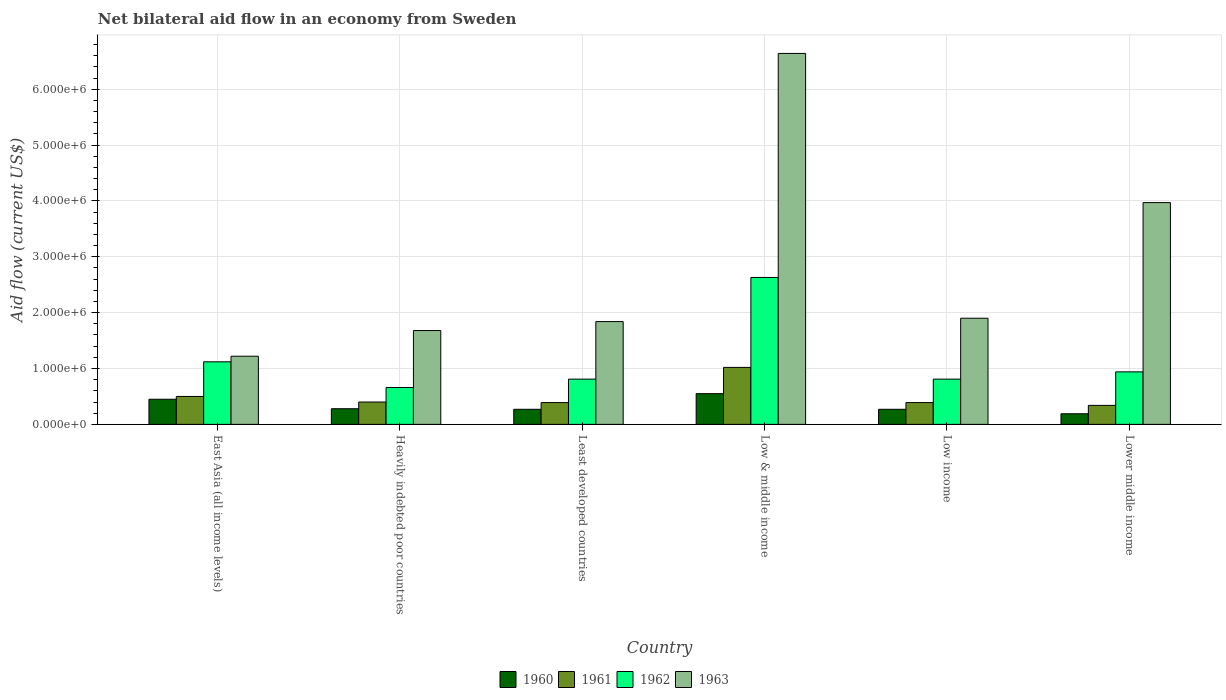Are the number of bars per tick equal to the number of legend labels?
Provide a succinct answer. Yes. Are the number of bars on each tick of the X-axis equal?
Make the answer very short. Yes. How many bars are there on the 6th tick from the left?
Keep it short and to the point. 4. How many bars are there on the 2nd tick from the right?
Make the answer very short. 4. What is the label of the 4th group of bars from the left?
Your answer should be compact. Low & middle income. What is the net bilateral aid flow in 1963 in Least developed countries?
Give a very brief answer. 1.84e+06. Across all countries, what is the maximum net bilateral aid flow in 1963?
Your response must be concise. 6.64e+06. In which country was the net bilateral aid flow in 1962 maximum?
Provide a short and direct response. Low & middle income. In which country was the net bilateral aid flow in 1961 minimum?
Offer a very short reply. Lower middle income. What is the total net bilateral aid flow in 1962 in the graph?
Offer a very short reply. 6.97e+06. What is the difference between the net bilateral aid flow in 1961 in Heavily indebted poor countries and that in Low & middle income?
Ensure brevity in your answer.  -6.20e+05. What is the average net bilateral aid flow in 1963 per country?
Your answer should be very brief. 2.88e+06. In how many countries, is the net bilateral aid flow in 1961 greater than 3200000 US$?
Provide a short and direct response. 0. What is the ratio of the net bilateral aid flow in 1962 in East Asia (all income levels) to that in Heavily indebted poor countries?
Your answer should be compact. 1.7. Is the net bilateral aid flow in 1963 in Low & middle income less than that in Lower middle income?
Provide a succinct answer. No. What is the difference between the highest and the lowest net bilateral aid flow in 1962?
Your answer should be compact. 1.97e+06. In how many countries, is the net bilateral aid flow in 1963 greater than the average net bilateral aid flow in 1963 taken over all countries?
Provide a short and direct response. 2. What does the 4th bar from the right in Low & middle income represents?
Provide a succinct answer. 1960. Is it the case that in every country, the sum of the net bilateral aid flow in 1960 and net bilateral aid flow in 1963 is greater than the net bilateral aid flow in 1961?
Ensure brevity in your answer.  Yes. How many bars are there?
Your answer should be compact. 24. Are all the bars in the graph horizontal?
Provide a succinct answer. No. How many countries are there in the graph?
Your answer should be compact. 6. What is the difference between two consecutive major ticks on the Y-axis?
Your response must be concise. 1.00e+06. Are the values on the major ticks of Y-axis written in scientific E-notation?
Give a very brief answer. Yes. Where does the legend appear in the graph?
Your response must be concise. Bottom center. How many legend labels are there?
Offer a very short reply. 4. What is the title of the graph?
Make the answer very short. Net bilateral aid flow in an economy from Sweden. What is the label or title of the Y-axis?
Your answer should be compact. Aid flow (current US$). What is the Aid flow (current US$) in 1962 in East Asia (all income levels)?
Offer a very short reply. 1.12e+06. What is the Aid flow (current US$) of 1963 in East Asia (all income levels)?
Your response must be concise. 1.22e+06. What is the Aid flow (current US$) of 1961 in Heavily indebted poor countries?
Keep it short and to the point. 4.00e+05. What is the Aid flow (current US$) of 1963 in Heavily indebted poor countries?
Offer a terse response. 1.68e+06. What is the Aid flow (current US$) in 1960 in Least developed countries?
Offer a terse response. 2.70e+05. What is the Aid flow (current US$) in 1961 in Least developed countries?
Make the answer very short. 3.90e+05. What is the Aid flow (current US$) of 1962 in Least developed countries?
Give a very brief answer. 8.10e+05. What is the Aid flow (current US$) in 1963 in Least developed countries?
Make the answer very short. 1.84e+06. What is the Aid flow (current US$) in 1961 in Low & middle income?
Keep it short and to the point. 1.02e+06. What is the Aid flow (current US$) of 1962 in Low & middle income?
Keep it short and to the point. 2.63e+06. What is the Aid flow (current US$) in 1963 in Low & middle income?
Your response must be concise. 6.64e+06. What is the Aid flow (current US$) in 1962 in Low income?
Offer a terse response. 8.10e+05. What is the Aid flow (current US$) in 1963 in Low income?
Keep it short and to the point. 1.90e+06. What is the Aid flow (current US$) in 1962 in Lower middle income?
Ensure brevity in your answer.  9.40e+05. What is the Aid flow (current US$) in 1963 in Lower middle income?
Keep it short and to the point. 3.97e+06. Across all countries, what is the maximum Aid flow (current US$) in 1960?
Your answer should be very brief. 5.50e+05. Across all countries, what is the maximum Aid flow (current US$) of 1961?
Keep it short and to the point. 1.02e+06. Across all countries, what is the maximum Aid flow (current US$) in 1962?
Offer a terse response. 2.63e+06. Across all countries, what is the maximum Aid flow (current US$) of 1963?
Provide a succinct answer. 6.64e+06. Across all countries, what is the minimum Aid flow (current US$) in 1961?
Your response must be concise. 3.40e+05. Across all countries, what is the minimum Aid flow (current US$) of 1962?
Provide a succinct answer. 6.60e+05. Across all countries, what is the minimum Aid flow (current US$) of 1963?
Make the answer very short. 1.22e+06. What is the total Aid flow (current US$) in 1960 in the graph?
Keep it short and to the point. 2.01e+06. What is the total Aid flow (current US$) of 1961 in the graph?
Your answer should be very brief. 3.04e+06. What is the total Aid flow (current US$) of 1962 in the graph?
Offer a terse response. 6.97e+06. What is the total Aid flow (current US$) in 1963 in the graph?
Offer a very short reply. 1.72e+07. What is the difference between the Aid flow (current US$) in 1961 in East Asia (all income levels) and that in Heavily indebted poor countries?
Ensure brevity in your answer.  1.00e+05. What is the difference between the Aid flow (current US$) in 1962 in East Asia (all income levels) and that in Heavily indebted poor countries?
Your answer should be very brief. 4.60e+05. What is the difference between the Aid flow (current US$) of 1963 in East Asia (all income levels) and that in Heavily indebted poor countries?
Your answer should be very brief. -4.60e+05. What is the difference between the Aid flow (current US$) in 1960 in East Asia (all income levels) and that in Least developed countries?
Ensure brevity in your answer.  1.80e+05. What is the difference between the Aid flow (current US$) of 1961 in East Asia (all income levels) and that in Least developed countries?
Make the answer very short. 1.10e+05. What is the difference between the Aid flow (current US$) of 1963 in East Asia (all income levels) and that in Least developed countries?
Your answer should be compact. -6.20e+05. What is the difference between the Aid flow (current US$) of 1960 in East Asia (all income levels) and that in Low & middle income?
Offer a very short reply. -1.00e+05. What is the difference between the Aid flow (current US$) of 1961 in East Asia (all income levels) and that in Low & middle income?
Make the answer very short. -5.20e+05. What is the difference between the Aid flow (current US$) of 1962 in East Asia (all income levels) and that in Low & middle income?
Your answer should be compact. -1.51e+06. What is the difference between the Aid flow (current US$) of 1963 in East Asia (all income levels) and that in Low & middle income?
Your response must be concise. -5.42e+06. What is the difference between the Aid flow (current US$) of 1963 in East Asia (all income levels) and that in Low income?
Offer a terse response. -6.80e+05. What is the difference between the Aid flow (current US$) in 1960 in East Asia (all income levels) and that in Lower middle income?
Keep it short and to the point. 2.60e+05. What is the difference between the Aid flow (current US$) of 1963 in East Asia (all income levels) and that in Lower middle income?
Offer a terse response. -2.75e+06. What is the difference between the Aid flow (current US$) of 1960 in Heavily indebted poor countries and that in Least developed countries?
Give a very brief answer. 10000. What is the difference between the Aid flow (current US$) of 1961 in Heavily indebted poor countries and that in Least developed countries?
Keep it short and to the point. 10000. What is the difference between the Aid flow (current US$) of 1961 in Heavily indebted poor countries and that in Low & middle income?
Your answer should be very brief. -6.20e+05. What is the difference between the Aid flow (current US$) in 1962 in Heavily indebted poor countries and that in Low & middle income?
Ensure brevity in your answer.  -1.97e+06. What is the difference between the Aid flow (current US$) of 1963 in Heavily indebted poor countries and that in Low & middle income?
Your answer should be compact. -4.96e+06. What is the difference between the Aid flow (current US$) of 1960 in Heavily indebted poor countries and that in Low income?
Provide a short and direct response. 10000. What is the difference between the Aid flow (current US$) of 1961 in Heavily indebted poor countries and that in Low income?
Make the answer very short. 10000. What is the difference between the Aid flow (current US$) of 1962 in Heavily indebted poor countries and that in Low income?
Provide a succinct answer. -1.50e+05. What is the difference between the Aid flow (current US$) of 1960 in Heavily indebted poor countries and that in Lower middle income?
Make the answer very short. 9.00e+04. What is the difference between the Aid flow (current US$) of 1961 in Heavily indebted poor countries and that in Lower middle income?
Offer a terse response. 6.00e+04. What is the difference between the Aid flow (current US$) of 1962 in Heavily indebted poor countries and that in Lower middle income?
Provide a short and direct response. -2.80e+05. What is the difference between the Aid flow (current US$) in 1963 in Heavily indebted poor countries and that in Lower middle income?
Your response must be concise. -2.29e+06. What is the difference between the Aid flow (current US$) of 1960 in Least developed countries and that in Low & middle income?
Your response must be concise. -2.80e+05. What is the difference between the Aid flow (current US$) in 1961 in Least developed countries and that in Low & middle income?
Provide a short and direct response. -6.30e+05. What is the difference between the Aid flow (current US$) in 1962 in Least developed countries and that in Low & middle income?
Offer a very short reply. -1.82e+06. What is the difference between the Aid flow (current US$) of 1963 in Least developed countries and that in Low & middle income?
Ensure brevity in your answer.  -4.80e+06. What is the difference between the Aid flow (current US$) in 1960 in Least developed countries and that in Low income?
Provide a succinct answer. 0. What is the difference between the Aid flow (current US$) in 1961 in Least developed countries and that in Low income?
Make the answer very short. 0. What is the difference between the Aid flow (current US$) in 1962 in Least developed countries and that in Low income?
Ensure brevity in your answer.  0. What is the difference between the Aid flow (current US$) of 1963 in Least developed countries and that in Low income?
Your answer should be very brief. -6.00e+04. What is the difference between the Aid flow (current US$) of 1960 in Least developed countries and that in Lower middle income?
Provide a succinct answer. 8.00e+04. What is the difference between the Aid flow (current US$) in 1961 in Least developed countries and that in Lower middle income?
Offer a terse response. 5.00e+04. What is the difference between the Aid flow (current US$) in 1963 in Least developed countries and that in Lower middle income?
Ensure brevity in your answer.  -2.13e+06. What is the difference between the Aid flow (current US$) of 1960 in Low & middle income and that in Low income?
Offer a very short reply. 2.80e+05. What is the difference between the Aid flow (current US$) of 1961 in Low & middle income and that in Low income?
Offer a very short reply. 6.30e+05. What is the difference between the Aid flow (current US$) in 1962 in Low & middle income and that in Low income?
Keep it short and to the point. 1.82e+06. What is the difference between the Aid flow (current US$) in 1963 in Low & middle income and that in Low income?
Your response must be concise. 4.74e+06. What is the difference between the Aid flow (current US$) in 1961 in Low & middle income and that in Lower middle income?
Provide a succinct answer. 6.80e+05. What is the difference between the Aid flow (current US$) in 1962 in Low & middle income and that in Lower middle income?
Make the answer very short. 1.69e+06. What is the difference between the Aid flow (current US$) of 1963 in Low & middle income and that in Lower middle income?
Your answer should be very brief. 2.67e+06. What is the difference between the Aid flow (current US$) in 1962 in Low income and that in Lower middle income?
Your answer should be compact. -1.30e+05. What is the difference between the Aid flow (current US$) of 1963 in Low income and that in Lower middle income?
Offer a very short reply. -2.07e+06. What is the difference between the Aid flow (current US$) in 1960 in East Asia (all income levels) and the Aid flow (current US$) in 1961 in Heavily indebted poor countries?
Your answer should be very brief. 5.00e+04. What is the difference between the Aid flow (current US$) in 1960 in East Asia (all income levels) and the Aid flow (current US$) in 1962 in Heavily indebted poor countries?
Offer a terse response. -2.10e+05. What is the difference between the Aid flow (current US$) of 1960 in East Asia (all income levels) and the Aid flow (current US$) of 1963 in Heavily indebted poor countries?
Offer a very short reply. -1.23e+06. What is the difference between the Aid flow (current US$) in 1961 in East Asia (all income levels) and the Aid flow (current US$) in 1962 in Heavily indebted poor countries?
Your answer should be compact. -1.60e+05. What is the difference between the Aid flow (current US$) of 1961 in East Asia (all income levels) and the Aid flow (current US$) of 1963 in Heavily indebted poor countries?
Offer a very short reply. -1.18e+06. What is the difference between the Aid flow (current US$) of 1962 in East Asia (all income levels) and the Aid flow (current US$) of 1963 in Heavily indebted poor countries?
Provide a short and direct response. -5.60e+05. What is the difference between the Aid flow (current US$) in 1960 in East Asia (all income levels) and the Aid flow (current US$) in 1962 in Least developed countries?
Offer a very short reply. -3.60e+05. What is the difference between the Aid flow (current US$) of 1960 in East Asia (all income levels) and the Aid flow (current US$) of 1963 in Least developed countries?
Offer a very short reply. -1.39e+06. What is the difference between the Aid flow (current US$) of 1961 in East Asia (all income levels) and the Aid flow (current US$) of 1962 in Least developed countries?
Make the answer very short. -3.10e+05. What is the difference between the Aid flow (current US$) in 1961 in East Asia (all income levels) and the Aid flow (current US$) in 1963 in Least developed countries?
Provide a succinct answer. -1.34e+06. What is the difference between the Aid flow (current US$) in 1962 in East Asia (all income levels) and the Aid flow (current US$) in 1963 in Least developed countries?
Provide a succinct answer. -7.20e+05. What is the difference between the Aid flow (current US$) in 1960 in East Asia (all income levels) and the Aid flow (current US$) in 1961 in Low & middle income?
Offer a very short reply. -5.70e+05. What is the difference between the Aid flow (current US$) of 1960 in East Asia (all income levels) and the Aid flow (current US$) of 1962 in Low & middle income?
Your response must be concise. -2.18e+06. What is the difference between the Aid flow (current US$) in 1960 in East Asia (all income levels) and the Aid flow (current US$) in 1963 in Low & middle income?
Offer a very short reply. -6.19e+06. What is the difference between the Aid flow (current US$) of 1961 in East Asia (all income levels) and the Aid flow (current US$) of 1962 in Low & middle income?
Offer a very short reply. -2.13e+06. What is the difference between the Aid flow (current US$) of 1961 in East Asia (all income levels) and the Aid flow (current US$) of 1963 in Low & middle income?
Make the answer very short. -6.14e+06. What is the difference between the Aid flow (current US$) in 1962 in East Asia (all income levels) and the Aid flow (current US$) in 1963 in Low & middle income?
Provide a succinct answer. -5.52e+06. What is the difference between the Aid flow (current US$) in 1960 in East Asia (all income levels) and the Aid flow (current US$) in 1961 in Low income?
Offer a terse response. 6.00e+04. What is the difference between the Aid flow (current US$) of 1960 in East Asia (all income levels) and the Aid flow (current US$) of 1962 in Low income?
Your answer should be compact. -3.60e+05. What is the difference between the Aid flow (current US$) of 1960 in East Asia (all income levels) and the Aid flow (current US$) of 1963 in Low income?
Make the answer very short. -1.45e+06. What is the difference between the Aid flow (current US$) in 1961 in East Asia (all income levels) and the Aid flow (current US$) in 1962 in Low income?
Your answer should be compact. -3.10e+05. What is the difference between the Aid flow (current US$) of 1961 in East Asia (all income levels) and the Aid flow (current US$) of 1963 in Low income?
Offer a very short reply. -1.40e+06. What is the difference between the Aid flow (current US$) of 1962 in East Asia (all income levels) and the Aid flow (current US$) of 1963 in Low income?
Offer a very short reply. -7.80e+05. What is the difference between the Aid flow (current US$) of 1960 in East Asia (all income levels) and the Aid flow (current US$) of 1962 in Lower middle income?
Give a very brief answer. -4.90e+05. What is the difference between the Aid flow (current US$) in 1960 in East Asia (all income levels) and the Aid flow (current US$) in 1963 in Lower middle income?
Provide a succinct answer. -3.52e+06. What is the difference between the Aid flow (current US$) in 1961 in East Asia (all income levels) and the Aid flow (current US$) in 1962 in Lower middle income?
Offer a very short reply. -4.40e+05. What is the difference between the Aid flow (current US$) in 1961 in East Asia (all income levels) and the Aid flow (current US$) in 1963 in Lower middle income?
Offer a terse response. -3.47e+06. What is the difference between the Aid flow (current US$) in 1962 in East Asia (all income levels) and the Aid flow (current US$) in 1963 in Lower middle income?
Your response must be concise. -2.85e+06. What is the difference between the Aid flow (current US$) of 1960 in Heavily indebted poor countries and the Aid flow (current US$) of 1961 in Least developed countries?
Offer a terse response. -1.10e+05. What is the difference between the Aid flow (current US$) of 1960 in Heavily indebted poor countries and the Aid flow (current US$) of 1962 in Least developed countries?
Keep it short and to the point. -5.30e+05. What is the difference between the Aid flow (current US$) in 1960 in Heavily indebted poor countries and the Aid flow (current US$) in 1963 in Least developed countries?
Your answer should be very brief. -1.56e+06. What is the difference between the Aid flow (current US$) of 1961 in Heavily indebted poor countries and the Aid flow (current US$) of 1962 in Least developed countries?
Give a very brief answer. -4.10e+05. What is the difference between the Aid flow (current US$) of 1961 in Heavily indebted poor countries and the Aid flow (current US$) of 1963 in Least developed countries?
Ensure brevity in your answer.  -1.44e+06. What is the difference between the Aid flow (current US$) in 1962 in Heavily indebted poor countries and the Aid flow (current US$) in 1963 in Least developed countries?
Give a very brief answer. -1.18e+06. What is the difference between the Aid flow (current US$) in 1960 in Heavily indebted poor countries and the Aid flow (current US$) in 1961 in Low & middle income?
Ensure brevity in your answer.  -7.40e+05. What is the difference between the Aid flow (current US$) of 1960 in Heavily indebted poor countries and the Aid flow (current US$) of 1962 in Low & middle income?
Give a very brief answer. -2.35e+06. What is the difference between the Aid flow (current US$) in 1960 in Heavily indebted poor countries and the Aid flow (current US$) in 1963 in Low & middle income?
Offer a terse response. -6.36e+06. What is the difference between the Aid flow (current US$) in 1961 in Heavily indebted poor countries and the Aid flow (current US$) in 1962 in Low & middle income?
Your answer should be compact. -2.23e+06. What is the difference between the Aid flow (current US$) in 1961 in Heavily indebted poor countries and the Aid flow (current US$) in 1963 in Low & middle income?
Your answer should be very brief. -6.24e+06. What is the difference between the Aid flow (current US$) of 1962 in Heavily indebted poor countries and the Aid flow (current US$) of 1963 in Low & middle income?
Your response must be concise. -5.98e+06. What is the difference between the Aid flow (current US$) of 1960 in Heavily indebted poor countries and the Aid flow (current US$) of 1961 in Low income?
Your answer should be very brief. -1.10e+05. What is the difference between the Aid flow (current US$) in 1960 in Heavily indebted poor countries and the Aid flow (current US$) in 1962 in Low income?
Make the answer very short. -5.30e+05. What is the difference between the Aid flow (current US$) in 1960 in Heavily indebted poor countries and the Aid flow (current US$) in 1963 in Low income?
Give a very brief answer. -1.62e+06. What is the difference between the Aid flow (current US$) of 1961 in Heavily indebted poor countries and the Aid flow (current US$) of 1962 in Low income?
Keep it short and to the point. -4.10e+05. What is the difference between the Aid flow (current US$) of 1961 in Heavily indebted poor countries and the Aid flow (current US$) of 1963 in Low income?
Keep it short and to the point. -1.50e+06. What is the difference between the Aid flow (current US$) of 1962 in Heavily indebted poor countries and the Aid flow (current US$) of 1963 in Low income?
Provide a succinct answer. -1.24e+06. What is the difference between the Aid flow (current US$) in 1960 in Heavily indebted poor countries and the Aid flow (current US$) in 1961 in Lower middle income?
Provide a short and direct response. -6.00e+04. What is the difference between the Aid flow (current US$) in 1960 in Heavily indebted poor countries and the Aid flow (current US$) in 1962 in Lower middle income?
Offer a terse response. -6.60e+05. What is the difference between the Aid flow (current US$) in 1960 in Heavily indebted poor countries and the Aid flow (current US$) in 1963 in Lower middle income?
Keep it short and to the point. -3.69e+06. What is the difference between the Aid flow (current US$) of 1961 in Heavily indebted poor countries and the Aid flow (current US$) of 1962 in Lower middle income?
Your answer should be very brief. -5.40e+05. What is the difference between the Aid flow (current US$) in 1961 in Heavily indebted poor countries and the Aid flow (current US$) in 1963 in Lower middle income?
Provide a short and direct response. -3.57e+06. What is the difference between the Aid flow (current US$) in 1962 in Heavily indebted poor countries and the Aid flow (current US$) in 1963 in Lower middle income?
Give a very brief answer. -3.31e+06. What is the difference between the Aid flow (current US$) in 1960 in Least developed countries and the Aid flow (current US$) in 1961 in Low & middle income?
Keep it short and to the point. -7.50e+05. What is the difference between the Aid flow (current US$) in 1960 in Least developed countries and the Aid flow (current US$) in 1962 in Low & middle income?
Your answer should be very brief. -2.36e+06. What is the difference between the Aid flow (current US$) of 1960 in Least developed countries and the Aid flow (current US$) of 1963 in Low & middle income?
Make the answer very short. -6.37e+06. What is the difference between the Aid flow (current US$) in 1961 in Least developed countries and the Aid flow (current US$) in 1962 in Low & middle income?
Provide a short and direct response. -2.24e+06. What is the difference between the Aid flow (current US$) in 1961 in Least developed countries and the Aid flow (current US$) in 1963 in Low & middle income?
Provide a succinct answer. -6.25e+06. What is the difference between the Aid flow (current US$) of 1962 in Least developed countries and the Aid flow (current US$) of 1963 in Low & middle income?
Keep it short and to the point. -5.83e+06. What is the difference between the Aid flow (current US$) in 1960 in Least developed countries and the Aid flow (current US$) in 1962 in Low income?
Ensure brevity in your answer.  -5.40e+05. What is the difference between the Aid flow (current US$) of 1960 in Least developed countries and the Aid flow (current US$) of 1963 in Low income?
Keep it short and to the point. -1.63e+06. What is the difference between the Aid flow (current US$) of 1961 in Least developed countries and the Aid flow (current US$) of 1962 in Low income?
Provide a short and direct response. -4.20e+05. What is the difference between the Aid flow (current US$) in 1961 in Least developed countries and the Aid flow (current US$) in 1963 in Low income?
Keep it short and to the point. -1.51e+06. What is the difference between the Aid flow (current US$) of 1962 in Least developed countries and the Aid flow (current US$) of 1963 in Low income?
Provide a succinct answer. -1.09e+06. What is the difference between the Aid flow (current US$) in 1960 in Least developed countries and the Aid flow (current US$) in 1962 in Lower middle income?
Your answer should be very brief. -6.70e+05. What is the difference between the Aid flow (current US$) of 1960 in Least developed countries and the Aid flow (current US$) of 1963 in Lower middle income?
Your answer should be compact. -3.70e+06. What is the difference between the Aid flow (current US$) of 1961 in Least developed countries and the Aid flow (current US$) of 1962 in Lower middle income?
Your answer should be very brief. -5.50e+05. What is the difference between the Aid flow (current US$) in 1961 in Least developed countries and the Aid flow (current US$) in 1963 in Lower middle income?
Offer a very short reply. -3.58e+06. What is the difference between the Aid flow (current US$) in 1962 in Least developed countries and the Aid flow (current US$) in 1963 in Lower middle income?
Provide a succinct answer. -3.16e+06. What is the difference between the Aid flow (current US$) in 1960 in Low & middle income and the Aid flow (current US$) in 1961 in Low income?
Your answer should be compact. 1.60e+05. What is the difference between the Aid flow (current US$) in 1960 in Low & middle income and the Aid flow (current US$) in 1963 in Low income?
Make the answer very short. -1.35e+06. What is the difference between the Aid flow (current US$) of 1961 in Low & middle income and the Aid flow (current US$) of 1962 in Low income?
Give a very brief answer. 2.10e+05. What is the difference between the Aid flow (current US$) of 1961 in Low & middle income and the Aid flow (current US$) of 1963 in Low income?
Your response must be concise. -8.80e+05. What is the difference between the Aid flow (current US$) of 1962 in Low & middle income and the Aid flow (current US$) of 1963 in Low income?
Your answer should be compact. 7.30e+05. What is the difference between the Aid flow (current US$) in 1960 in Low & middle income and the Aid flow (current US$) in 1962 in Lower middle income?
Provide a succinct answer. -3.90e+05. What is the difference between the Aid flow (current US$) of 1960 in Low & middle income and the Aid flow (current US$) of 1963 in Lower middle income?
Make the answer very short. -3.42e+06. What is the difference between the Aid flow (current US$) of 1961 in Low & middle income and the Aid flow (current US$) of 1963 in Lower middle income?
Your answer should be compact. -2.95e+06. What is the difference between the Aid flow (current US$) of 1962 in Low & middle income and the Aid flow (current US$) of 1963 in Lower middle income?
Ensure brevity in your answer.  -1.34e+06. What is the difference between the Aid flow (current US$) of 1960 in Low income and the Aid flow (current US$) of 1962 in Lower middle income?
Make the answer very short. -6.70e+05. What is the difference between the Aid flow (current US$) of 1960 in Low income and the Aid flow (current US$) of 1963 in Lower middle income?
Your answer should be very brief. -3.70e+06. What is the difference between the Aid flow (current US$) in 1961 in Low income and the Aid flow (current US$) in 1962 in Lower middle income?
Provide a succinct answer. -5.50e+05. What is the difference between the Aid flow (current US$) in 1961 in Low income and the Aid flow (current US$) in 1963 in Lower middle income?
Your answer should be compact. -3.58e+06. What is the difference between the Aid flow (current US$) of 1962 in Low income and the Aid flow (current US$) of 1963 in Lower middle income?
Provide a short and direct response. -3.16e+06. What is the average Aid flow (current US$) in 1960 per country?
Ensure brevity in your answer.  3.35e+05. What is the average Aid flow (current US$) of 1961 per country?
Your answer should be compact. 5.07e+05. What is the average Aid flow (current US$) in 1962 per country?
Ensure brevity in your answer.  1.16e+06. What is the average Aid flow (current US$) of 1963 per country?
Your answer should be very brief. 2.88e+06. What is the difference between the Aid flow (current US$) of 1960 and Aid flow (current US$) of 1962 in East Asia (all income levels)?
Offer a very short reply. -6.70e+05. What is the difference between the Aid flow (current US$) of 1960 and Aid flow (current US$) of 1963 in East Asia (all income levels)?
Your answer should be compact. -7.70e+05. What is the difference between the Aid flow (current US$) of 1961 and Aid flow (current US$) of 1962 in East Asia (all income levels)?
Give a very brief answer. -6.20e+05. What is the difference between the Aid flow (current US$) in 1961 and Aid flow (current US$) in 1963 in East Asia (all income levels)?
Your answer should be compact. -7.20e+05. What is the difference between the Aid flow (current US$) in 1960 and Aid flow (current US$) in 1962 in Heavily indebted poor countries?
Make the answer very short. -3.80e+05. What is the difference between the Aid flow (current US$) in 1960 and Aid flow (current US$) in 1963 in Heavily indebted poor countries?
Your answer should be compact. -1.40e+06. What is the difference between the Aid flow (current US$) in 1961 and Aid flow (current US$) in 1962 in Heavily indebted poor countries?
Ensure brevity in your answer.  -2.60e+05. What is the difference between the Aid flow (current US$) in 1961 and Aid flow (current US$) in 1963 in Heavily indebted poor countries?
Your answer should be very brief. -1.28e+06. What is the difference between the Aid flow (current US$) in 1962 and Aid flow (current US$) in 1963 in Heavily indebted poor countries?
Keep it short and to the point. -1.02e+06. What is the difference between the Aid flow (current US$) in 1960 and Aid flow (current US$) in 1961 in Least developed countries?
Your response must be concise. -1.20e+05. What is the difference between the Aid flow (current US$) of 1960 and Aid flow (current US$) of 1962 in Least developed countries?
Your answer should be very brief. -5.40e+05. What is the difference between the Aid flow (current US$) of 1960 and Aid flow (current US$) of 1963 in Least developed countries?
Make the answer very short. -1.57e+06. What is the difference between the Aid flow (current US$) in 1961 and Aid flow (current US$) in 1962 in Least developed countries?
Your response must be concise. -4.20e+05. What is the difference between the Aid flow (current US$) in 1961 and Aid flow (current US$) in 1963 in Least developed countries?
Keep it short and to the point. -1.45e+06. What is the difference between the Aid flow (current US$) of 1962 and Aid flow (current US$) of 1963 in Least developed countries?
Offer a terse response. -1.03e+06. What is the difference between the Aid flow (current US$) in 1960 and Aid flow (current US$) in 1961 in Low & middle income?
Keep it short and to the point. -4.70e+05. What is the difference between the Aid flow (current US$) in 1960 and Aid flow (current US$) in 1962 in Low & middle income?
Provide a short and direct response. -2.08e+06. What is the difference between the Aid flow (current US$) of 1960 and Aid flow (current US$) of 1963 in Low & middle income?
Provide a short and direct response. -6.09e+06. What is the difference between the Aid flow (current US$) of 1961 and Aid flow (current US$) of 1962 in Low & middle income?
Provide a short and direct response. -1.61e+06. What is the difference between the Aid flow (current US$) of 1961 and Aid flow (current US$) of 1963 in Low & middle income?
Make the answer very short. -5.62e+06. What is the difference between the Aid flow (current US$) of 1962 and Aid flow (current US$) of 1963 in Low & middle income?
Your answer should be compact. -4.01e+06. What is the difference between the Aid flow (current US$) of 1960 and Aid flow (current US$) of 1961 in Low income?
Keep it short and to the point. -1.20e+05. What is the difference between the Aid flow (current US$) in 1960 and Aid flow (current US$) in 1962 in Low income?
Your response must be concise. -5.40e+05. What is the difference between the Aid flow (current US$) of 1960 and Aid flow (current US$) of 1963 in Low income?
Ensure brevity in your answer.  -1.63e+06. What is the difference between the Aid flow (current US$) of 1961 and Aid flow (current US$) of 1962 in Low income?
Offer a terse response. -4.20e+05. What is the difference between the Aid flow (current US$) in 1961 and Aid flow (current US$) in 1963 in Low income?
Your answer should be compact. -1.51e+06. What is the difference between the Aid flow (current US$) in 1962 and Aid flow (current US$) in 1963 in Low income?
Make the answer very short. -1.09e+06. What is the difference between the Aid flow (current US$) in 1960 and Aid flow (current US$) in 1961 in Lower middle income?
Your response must be concise. -1.50e+05. What is the difference between the Aid flow (current US$) in 1960 and Aid flow (current US$) in 1962 in Lower middle income?
Offer a very short reply. -7.50e+05. What is the difference between the Aid flow (current US$) of 1960 and Aid flow (current US$) of 1963 in Lower middle income?
Provide a succinct answer. -3.78e+06. What is the difference between the Aid flow (current US$) in 1961 and Aid flow (current US$) in 1962 in Lower middle income?
Offer a terse response. -6.00e+05. What is the difference between the Aid flow (current US$) in 1961 and Aid flow (current US$) in 1963 in Lower middle income?
Your answer should be very brief. -3.63e+06. What is the difference between the Aid flow (current US$) of 1962 and Aid flow (current US$) of 1963 in Lower middle income?
Offer a very short reply. -3.03e+06. What is the ratio of the Aid flow (current US$) of 1960 in East Asia (all income levels) to that in Heavily indebted poor countries?
Make the answer very short. 1.61. What is the ratio of the Aid flow (current US$) in 1961 in East Asia (all income levels) to that in Heavily indebted poor countries?
Make the answer very short. 1.25. What is the ratio of the Aid flow (current US$) of 1962 in East Asia (all income levels) to that in Heavily indebted poor countries?
Your answer should be compact. 1.7. What is the ratio of the Aid flow (current US$) of 1963 in East Asia (all income levels) to that in Heavily indebted poor countries?
Your response must be concise. 0.73. What is the ratio of the Aid flow (current US$) in 1961 in East Asia (all income levels) to that in Least developed countries?
Your answer should be compact. 1.28. What is the ratio of the Aid flow (current US$) of 1962 in East Asia (all income levels) to that in Least developed countries?
Your answer should be very brief. 1.38. What is the ratio of the Aid flow (current US$) of 1963 in East Asia (all income levels) to that in Least developed countries?
Provide a short and direct response. 0.66. What is the ratio of the Aid flow (current US$) in 1960 in East Asia (all income levels) to that in Low & middle income?
Make the answer very short. 0.82. What is the ratio of the Aid flow (current US$) in 1961 in East Asia (all income levels) to that in Low & middle income?
Your answer should be compact. 0.49. What is the ratio of the Aid flow (current US$) of 1962 in East Asia (all income levels) to that in Low & middle income?
Give a very brief answer. 0.43. What is the ratio of the Aid flow (current US$) of 1963 in East Asia (all income levels) to that in Low & middle income?
Provide a succinct answer. 0.18. What is the ratio of the Aid flow (current US$) in 1960 in East Asia (all income levels) to that in Low income?
Offer a very short reply. 1.67. What is the ratio of the Aid flow (current US$) of 1961 in East Asia (all income levels) to that in Low income?
Offer a very short reply. 1.28. What is the ratio of the Aid flow (current US$) in 1962 in East Asia (all income levels) to that in Low income?
Your answer should be compact. 1.38. What is the ratio of the Aid flow (current US$) of 1963 in East Asia (all income levels) to that in Low income?
Ensure brevity in your answer.  0.64. What is the ratio of the Aid flow (current US$) in 1960 in East Asia (all income levels) to that in Lower middle income?
Ensure brevity in your answer.  2.37. What is the ratio of the Aid flow (current US$) in 1961 in East Asia (all income levels) to that in Lower middle income?
Ensure brevity in your answer.  1.47. What is the ratio of the Aid flow (current US$) of 1962 in East Asia (all income levels) to that in Lower middle income?
Offer a terse response. 1.19. What is the ratio of the Aid flow (current US$) of 1963 in East Asia (all income levels) to that in Lower middle income?
Ensure brevity in your answer.  0.31. What is the ratio of the Aid flow (current US$) in 1961 in Heavily indebted poor countries to that in Least developed countries?
Provide a succinct answer. 1.03. What is the ratio of the Aid flow (current US$) in 1962 in Heavily indebted poor countries to that in Least developed countries?
Offer a terse response. 0.81. What is the ratio of the Aid flow (current US$) of 1963 in Heavily indebted poor countries to that in Least developed countries?
Offer a terse response. 0.91. What is the ratio of the Aid flow (current US$) in 1960 in Heavily indebted poor countries to that in Low & middle income?
Give a very brief answer. 0.51. What is the ratio of the Aid flow (current US$) of 1961 in Heavily indebted poor countries to that in Low & middle income?
Provide a succinct answer. 0.39. What is the ratio of the Aid flow (current US$) of 1962 in Heavily indebted poor countries to that in Low & middle income?
Your response must be concise. 0.25. What is the ratio of the Aid flow (current US$) of 1963 in Heavily indebted poor countries to that in Low & middle income?
Ensure brevity in your answer.  0.25. What is the ratio of the Aid flow (current US$) in 1960 in Heavily indebted poor countries to that in Low income?
Keep it short and to the point. 1.04. What is the ratio of the Aid flow (current US$) in 1961 in Heavily indebted poor countries to that in Low income?
Your answer should be very brief. 1.03. What is the ratio of the Aid flow (current US$) in 1962 in Heavily indebted poor countries to that in Low income?
Your answer should be very brief. 0.81. What is the ratio of the Aid flow (current US$) in 1963 in Heavily indebted poor countries to that in Low income?
Give a very brief answer. 0.88. What is the ratio of the Aid flow (current US$) in 1960 in Heavily indebted poor countries to that in Lower middle income?
Ensure brevity in your answer.  1.47. What is the ratio of the Aid flow (current US$) of 1961 in Heavily indebted poor countries to that in Lower middle income?
Offer a terse response. 1.18. What is the ratio of the Aid flow (current US$) in 1962 in Heavily indebted poor countries to that in Lower middle income?
Ensure brevity in your answer.  0.7. What is the ratio of the Aid flow (current US$) in 1963 in Heavily indebted poor countries to that in Lower middle income?
Keep it short and to the point. 0.42. What is the ratio of the Aid flow (current US$) in 1960 in Least developed countries to that in Low & middle income?
Give a very brief answer. 0.49. What is the ratio of the Aid flow (current US$) in 1961 in Least developed countries to that in Low & middle income?
Offer a terse response. 0.38. What is the ratio of the Aid flow (current US$) of 1962 in Least developed countries to that in Low & middle income?
Give a very brief answer. 0.31. What is the ratio of the Aid flow (current US$) in 1963 in Least developed countries to that in Low & middle income?
Offer a very short reply. 0.28. What is the ratio of the Aid flow (current US$) of 1961 in Least developed countries to that in Low income?
Give a very brief answer. 1. What is the ratio of the Aid flow (current US$) of 1963 in Least developed countries to that in Low income?
Your answer should be very brief. 0.97. What is the ratio of the Aid flow (current US$) of 1960 in Least developed countries to that in Lower middle income?
Make the answer very short. 1.42. What is the ratio of the Aid flow (current US$) in 1961 in Least developed countries to that in Lower middle income?
Provide a succinct answer. 1.15. What is the ratio of the Aid flow (current US$) in 1962 in Least developed countries to that in Lower middle income?
Offer a terse response. 0.86. What is the ratio of the Aid flow (current US$) of 1963 in Least developed countries to that in Lower middle income?
Provide a succinct answer. 0.46. What is the ratio of the Aid flow (current US$) in 1960 in Low & middle income to that in Low income?
Your response must be concise. 2.04. What is the ratio of the Aid flow (current US$) in 1961 in Low & middle income to that in Low income?
Give a very brief answer. 2.62. What is the ratio of the Aid flow (current US$) of 1962 in Low & middle income to that in Low income?
Give a very brief answer. 3.25. What is the ratio of the Aid flow (current US$) in 1963 in Low & middle income to that in Low income?
Your answer should be compact. 3.49. What is the ratio of the Aid flow (current US$) of 1960 in Low & middle income to that in Lower middle income?
Make the answer very short. 2.89. What is the ratio of the Aid flow (current US$) in 1961 in Low & middle income to that in Lower middle income?
Offer a terse response. 3. What is the ratio of the Aid flow (current US$) in 1962 in Low & middle income to that in Lower middle income?
Keep it short and to the point. 2.8. What is the ratio of the Aid flow (current US$) in 1963 in Low & middle income to that in Lower middle income?
Offer a terse response. 1.67. What is the ratio of the Aid flow (current US$) of 1960 in Low income to that in Lower middle income?
Your answer should be very brief. 1.42. What is the ratio of the Aid flow (current US$) in 1961 in Low income to that in Lower middle income?
Provide a short and direct response. 1.15. What is the ratio of the Aid flow (current US$) in 1962 in Low income to that in Lower middle income?
Your response must be concise. 0.86. What is the ratio of the Aid flow (current US$) in 1963 in Low income to that in Lower middle income?
Offer a very short reply. 0.48. What is the difference between the highest and the second highest Aid flow (current US$) in 1961?
Your answer should be very brief. 5.20e+05. What is the difference between the highest and the second highest Aid flow (current US$) of 1962?
Your answer should be very brief. 1.51e+06. What is the difference between the highest and the second highest Aid flow (current US$) in 1963?
Keep it short and to the point. 2.67e+06. What is the difference between the highest and the lowest Aid flow (current US$) of 1960?
Provide a short and direct response. 3.60e+05. What is the difference between the highest and the lowest Aid flow (current US$) of 1961?
Offer a very short reply. 6.80e+05. What is the difference between the highest and the lowest Aid flow (current US$) in 1962?
Your answer should be very brief. 1.97e+06. What is the difference between the highest and the lowest Aid flow (current US$) of 1963?
Provide a succinct answer. 5.42e+06. 